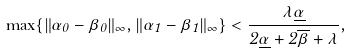Convert formula to latex. <formula><loc_0><loc_0><loc_500><loc_500>\max \{ \| \alpha _ { 0 } - \beta _ { 0 } \| _ { \infty } , \| \alpha _ { 1 } - \beta _ { 1 } \| _ { \infty } \} < \frac { \lambda \underline { \alpha } } { 2 \underline { \alpha } + 2 \overline { \beta } + \lambda } ,</formula> 